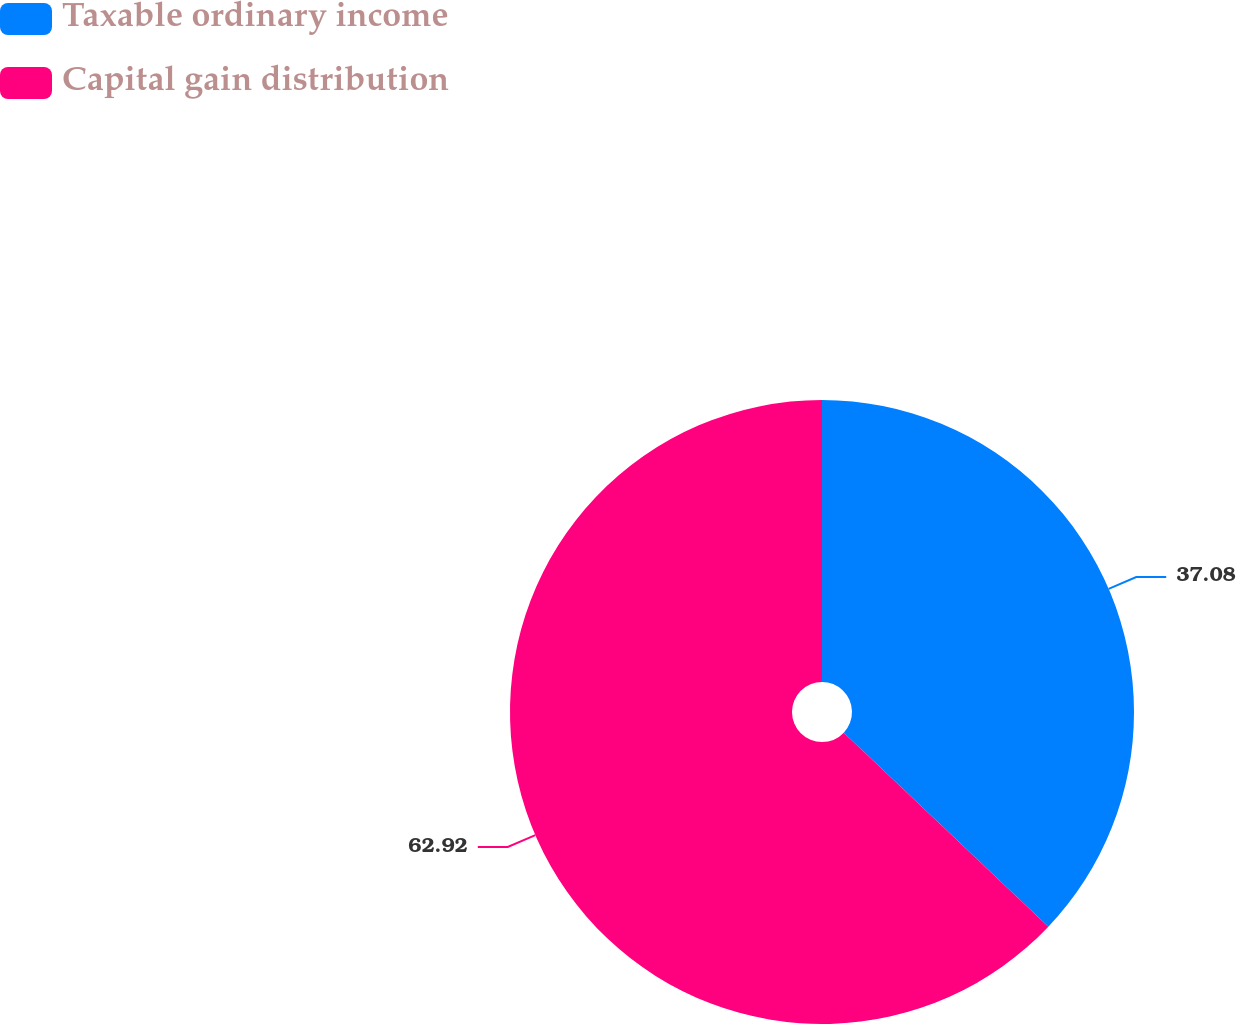Convert chart to OTSL. <chart><loc_0><loc_0><loc_500><loc_500><pie_chart><fcel>Taxable ordinary income<fcel>Capital gain distribution<nl><fcel>37.08%<fcel>62.92%<nl></chart> 